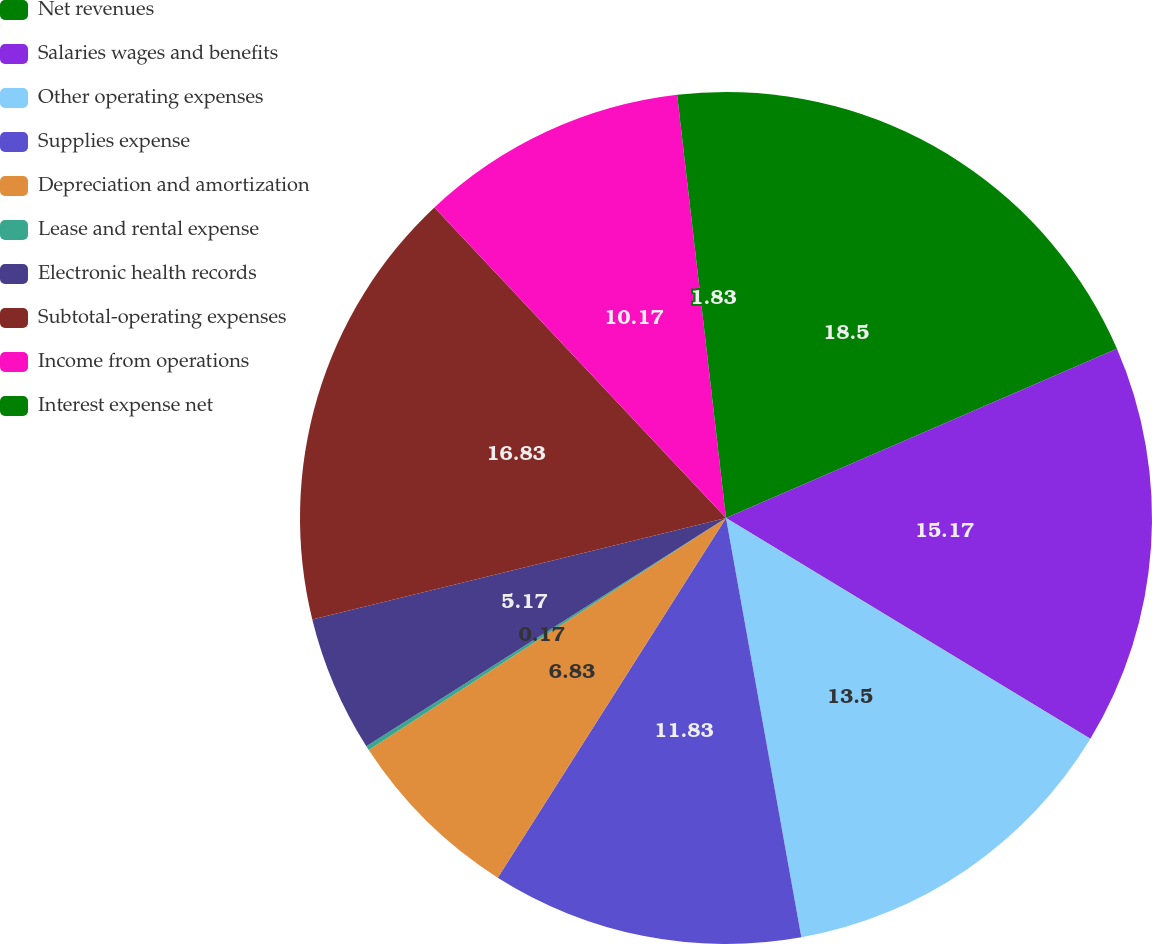Convert chart. <chart><loc_0><loc_0><loc_500><loc_500><pie_chart><fcel>Net revenues<fcel>Salaries wages and benefits<fcel>Other operating expenses<fcel>Supplies expense<fcel>Depreciation and amortization<fcel>Lease and rental expense<fcel>Electronic health records<fcel>Subtotal-operating expenses<fcel>Income from operations<fcel>Interest expense net<nl><fcel>18.5%<fcel>15.17%<fcel>13.5%<fcel>11.83%<fcel>6.83%<fcel>0.17%<fcel>5.17%<fcel>16.83%<fcel>10.17%<fcel>1.83%<nl></chart> 